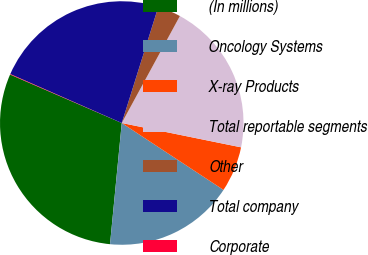<chart> <loc_0><loc_0><loc_500><loc_500><pie_chart><fcel>(In millions)<fcel>Oncology Systems<fcel>X-ray Products<fcel>Total reportable segments<fcel>Other<fcel>Total company<fcel>Corporate<nl><fcel>29.98%<fcel>17.28%<fcel>6.06%<fcel>20.28%<fcel>3.07%<fcel>23.27%<fcel>0.07%<nl></chart> 